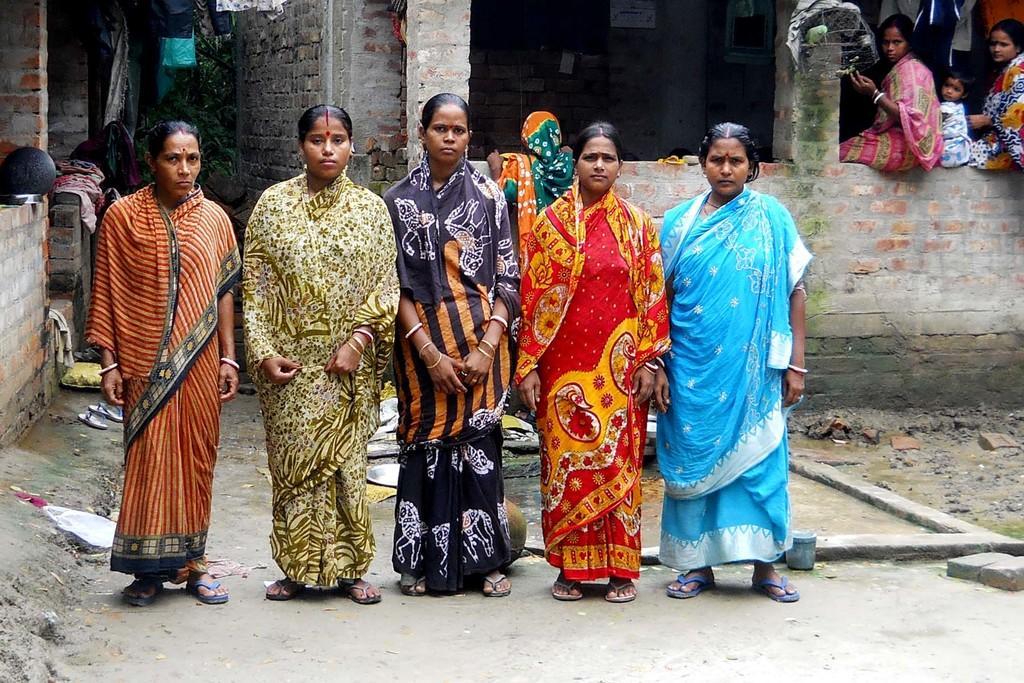Could you give a brief overview of what you see in this image? In this image I can see group of people standing. In front the person is wearing red and yellow color saree. In the background I can see few people sitting and I can also see few buildings. 